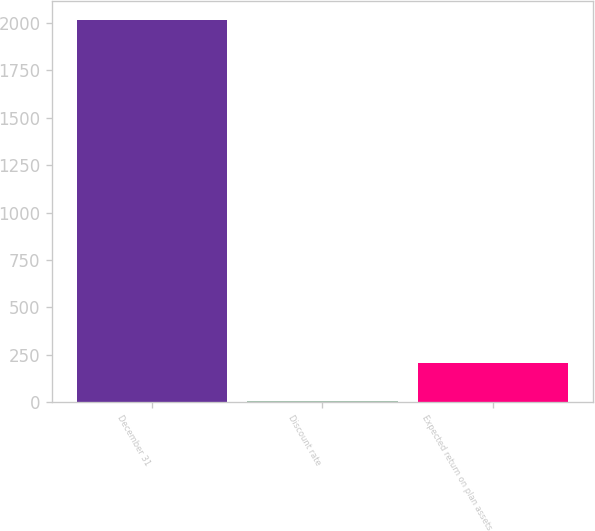<chart> <loc_0><loc_0><loc_500><loc_500><bar_chart><fcel>December 31<fcel>Discount rate<fcel>Expected return on plan assets<nl><fcel>2015<fcel>4.7<fcel>205.73<nl></chart> 